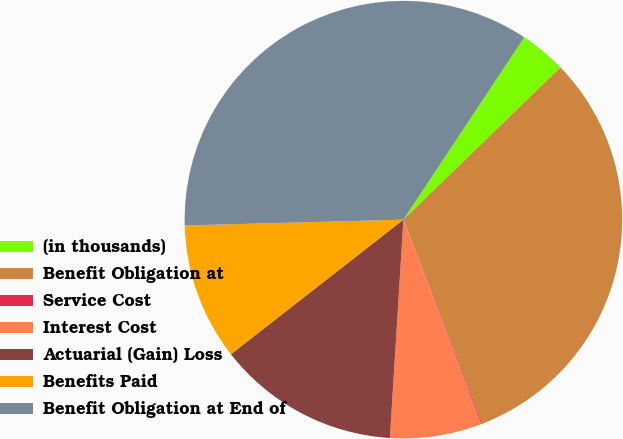Convert chart. <chart><loc_0><loc_0><loc_500><loc_500><pie_chart><fcel>(in thousands)<fcel>Benefit Obligation at<fcel>Service Cost<fcel>Interest Cost<fcel>Actuarial (Gain) Loss<fcel>Benefits Paid<fcel>Benefit Obligation at End of<nl><fcel>3.43%<fcel>31.39%<fcel>0.08%<fcel>6.77%<fcel>13.47%<fcel>10.12%<fcel>34.74%<nl></chart> 